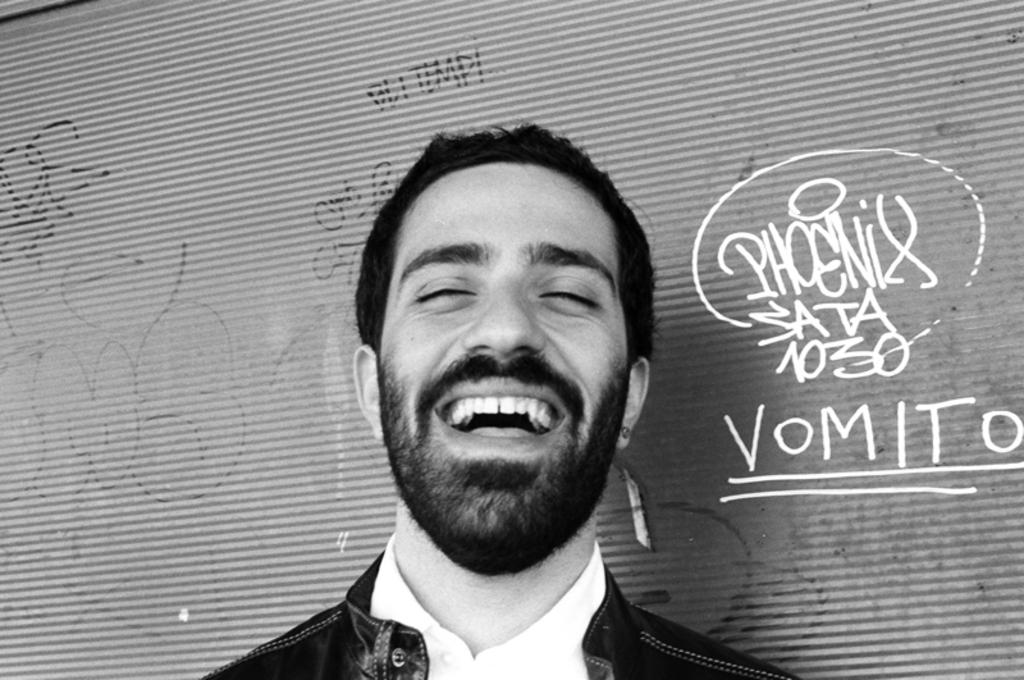What is the color scheme of the image? The image is black and white. Who is present in the image? There is a man in the image. What is the man doing in the image? The man is smiling in the image. What can be seen behind the man? There is a wall behind the man. What additional information is provided in the image? There is text written on the image. How many leaves can be seen falling in the image? There are no leaves present in the image, as it is a black and white image of a man smiling. 